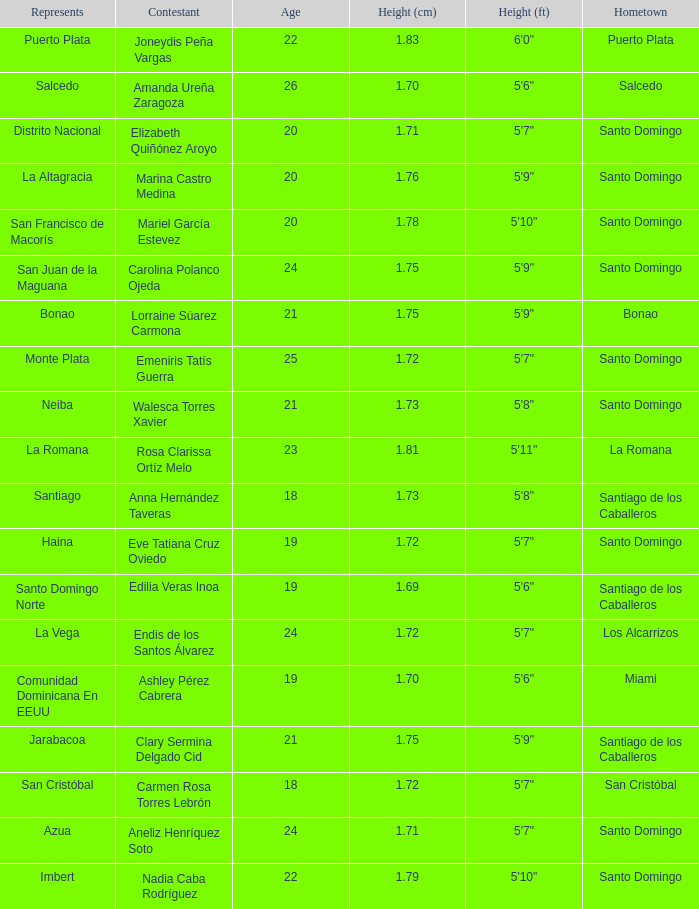Name the represents for los alcarrizos La Vega. 